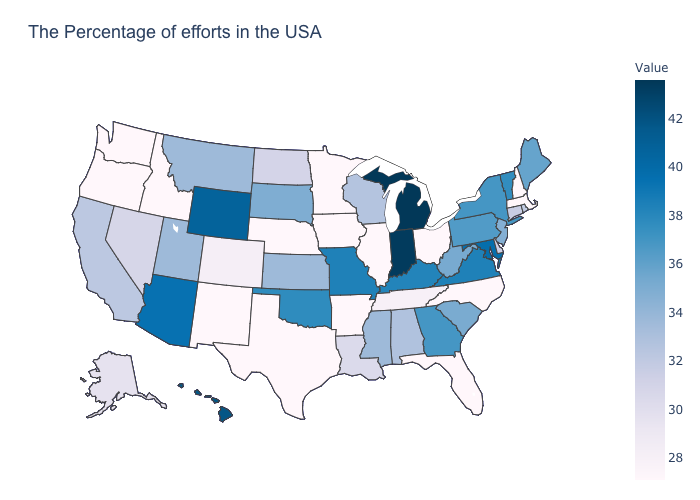Among the states that border Connecticut , which have the highest value?
Be succinct. New York. Among the states that border Texas , does Arkansas have the highest value?
Keep it brief. No. Does Vermont have a lower value than Kansas?
Write a very short answer. No. Which states have the highest value in the USA?
Write a very short answer. Michigan. 